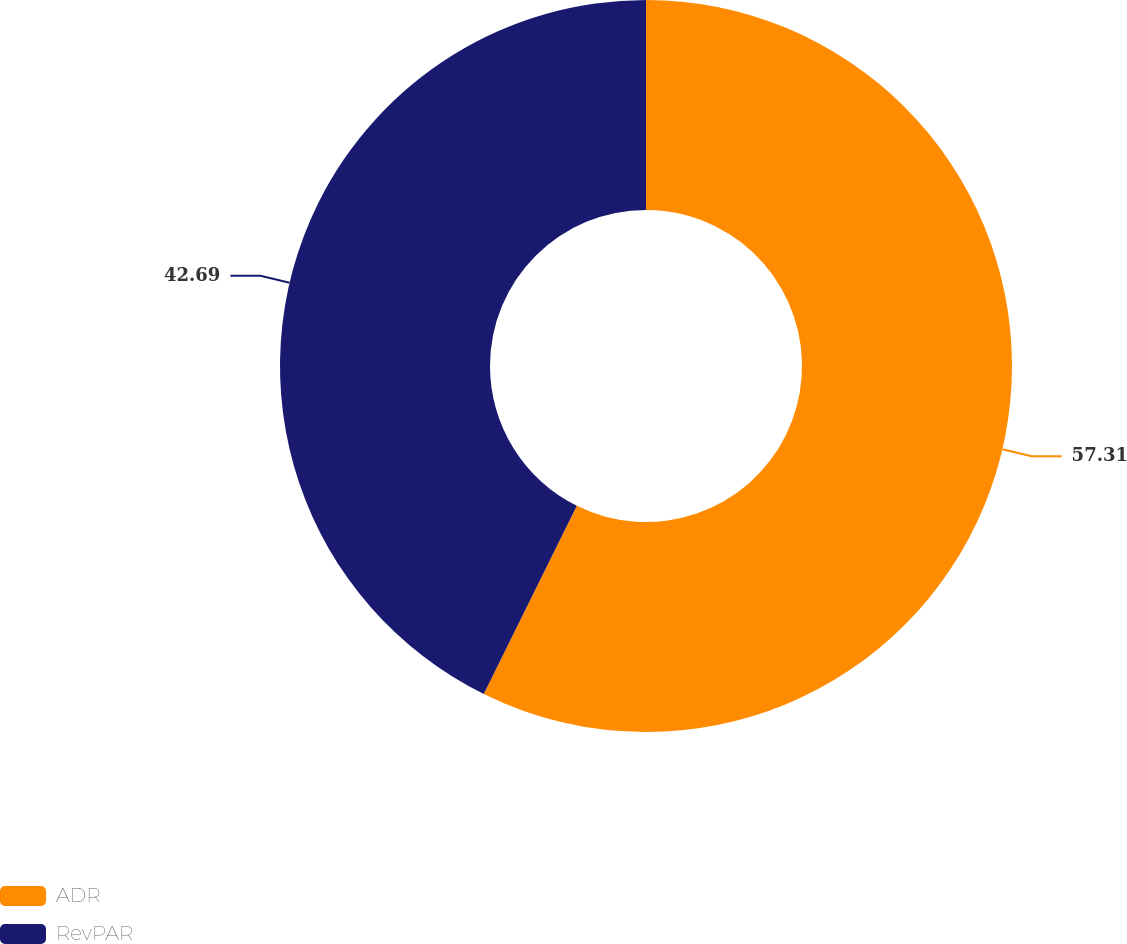<chart> <loc_0><loc_0><loc_500><loc_500><pie_chart><fcel>ADR<fcel>RevPAR<nl><fcel>57.31%<fcel>42.69%<nl></chart> 